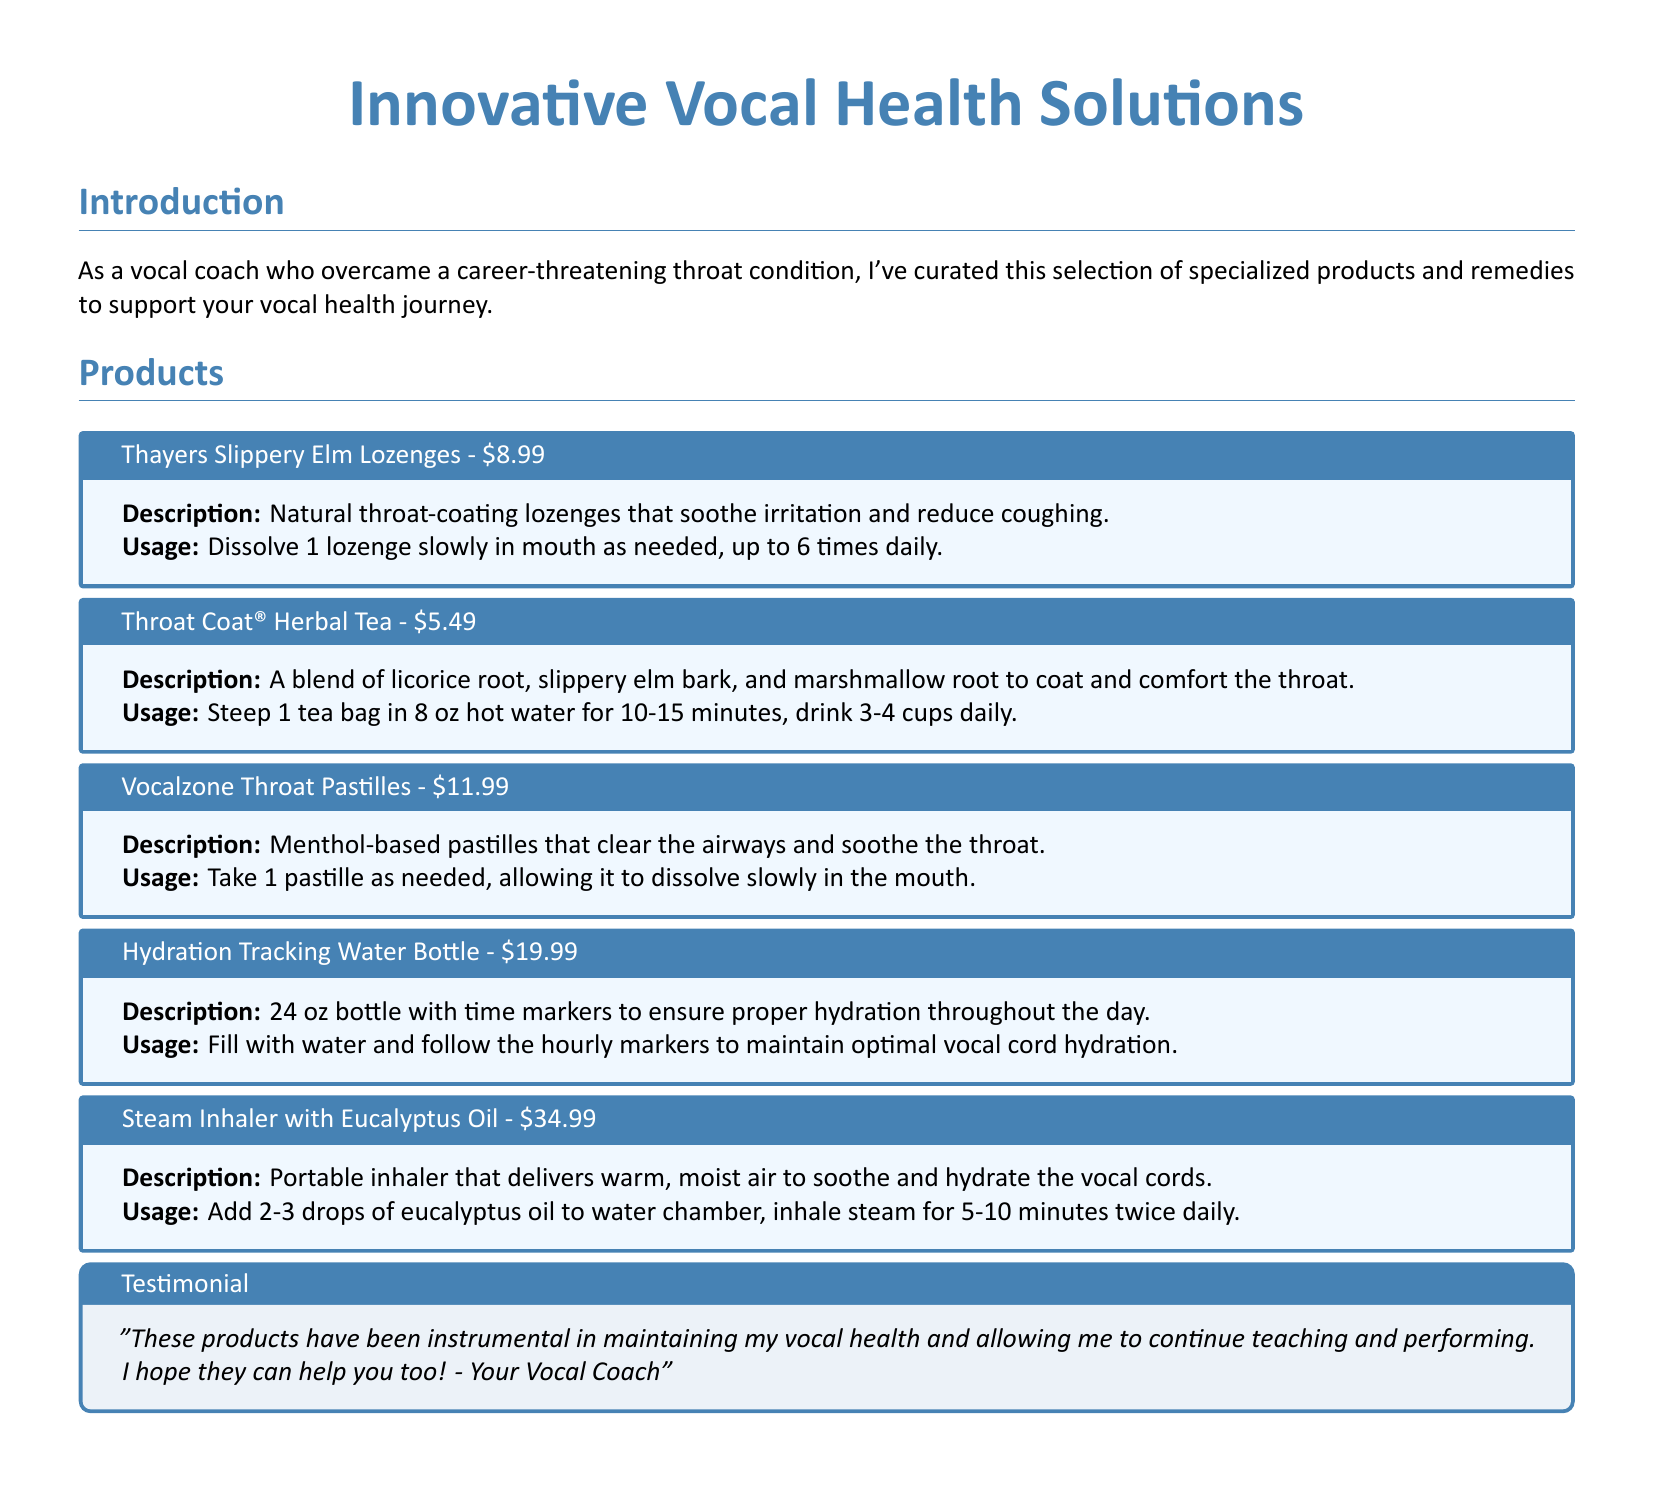What is the price of Thayers Slippery Elm Lozenges? The price is listed at the end of the product description.
Answer: $8.99 What ingredients are in Throat Coat® Herbal Tea? The ingredients are specified in the description of the product.
Answer: Licorice root, slippery elm bark, and marshmallow root How many cups of Throat Coat® Herbal Tea can be consumed daily? The usage instructions specify the daily limit.
Answer: 3-4 cups What is the capacity of the Hydration Tracking Water Bottle? The capacity is indicated in the description of the product.
Answer: 24 oz How often should the Steam Inhaler be used? The usage instructions state the frequency of inhalation.
Answer: Twice daily Which product is meant to clear the airways? The product that serves this purpose is specified in the document.
Answer: Vocalzone Throat Pastilles What is the purpose of the Hydration Tracking Water Bottle? The purpose is explained in the description of the product.
Answer: To ensure proper hydration What is the cost of the Steam Inhaler with Eucalyptus Oil? The amount is mentioned at the end of the product description.
Answer: $34.99 